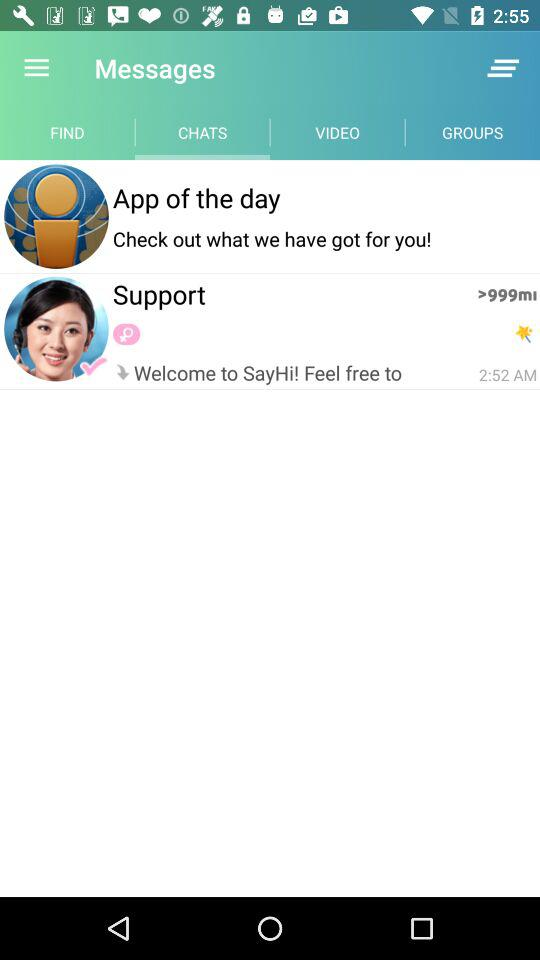When was the last time you received a message from support? The time was 2:52 AM. 